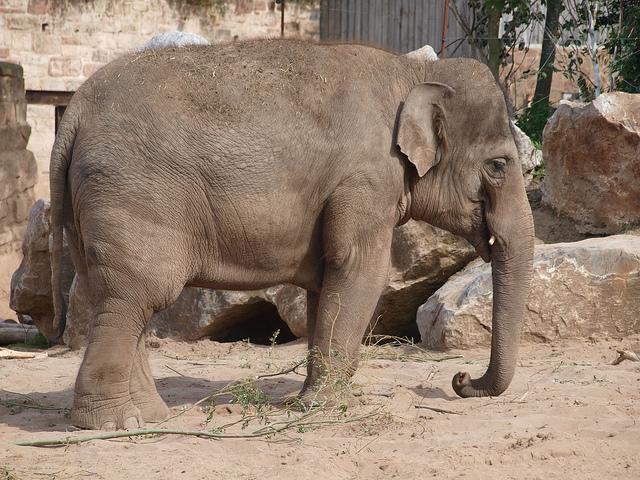How many adults elephants in this photo?
Give a very brief answer. 1. 